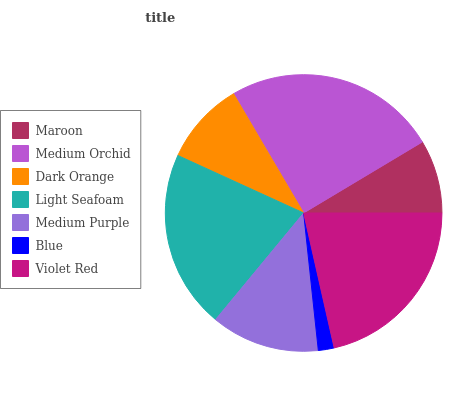Is Blue the minimum?
Answer yes or no. Yes. Is Medium Orchid the maximum?
Answer yes or no. Yes. Is Dark Orange the minimum?
Answer yes or no. No. Is Dark Orange the maximum?
Answer yes or no. No. Is Medium Orchid greater than Dark Orange?
Answer yes or no. Yes. Is Dark Orange less than Medium Orchid?
Answer yes or no. Yes. Is Dark Orange greater than Medium Orchid?
Answer yes or no. No. Is Medium Orchid less than Dark Orange?
Answer yes or no. No. Is Medium Purple the high median?
Answer yes or no. Yes. Is Medium Purple the low median?
Answer yes or no. Yes. Is Blue the high median?
Answer yes or no. No. Is Maroon the low median?
Answer yes or no. No. 